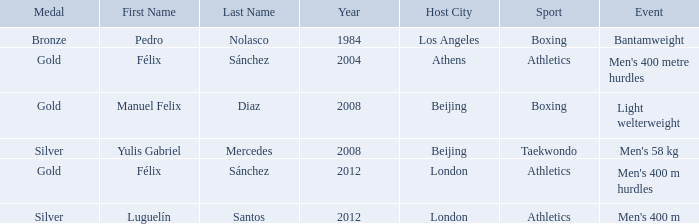Which name was associated with the 2008 beijing games and a gold medal? Manuel Felix Diaz. 